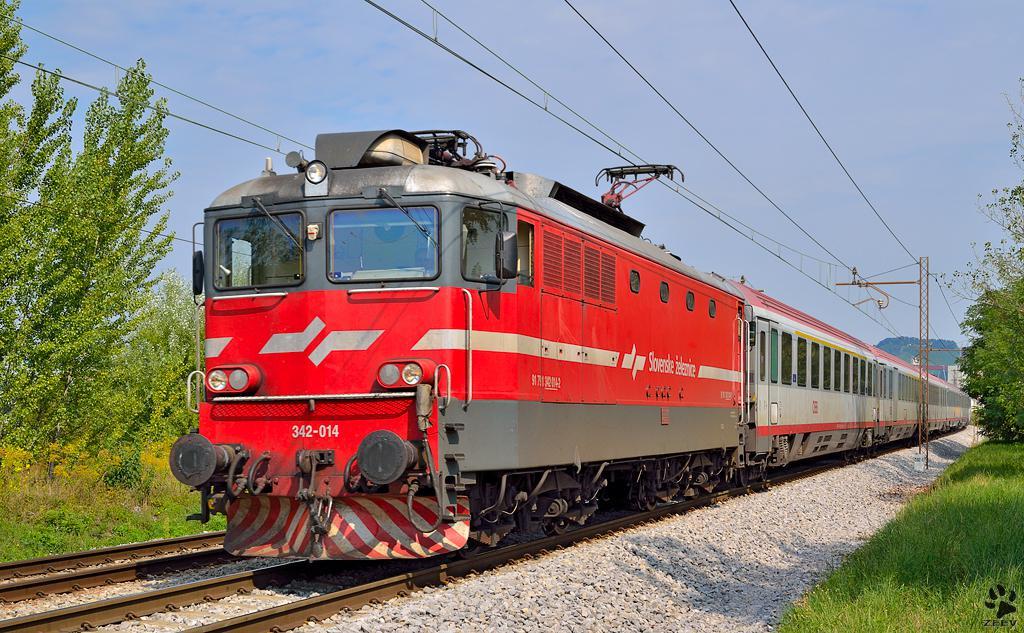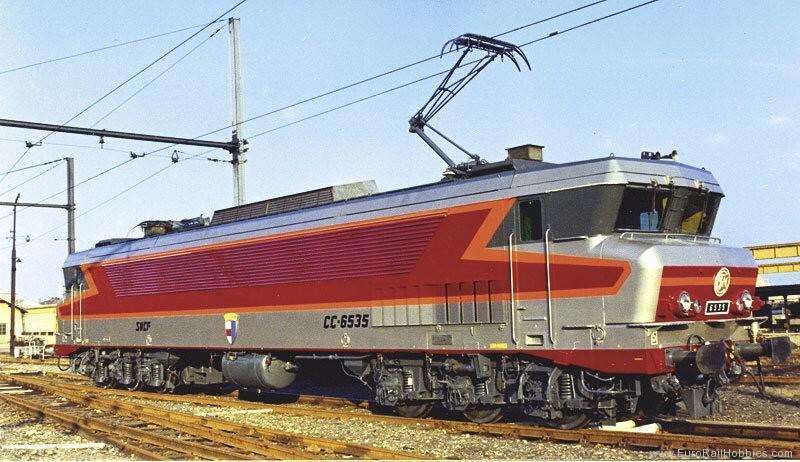The first image is the image on the left, the second image is the image on the right. Examine the images to the left and right. Is the description "The train engine in one of the images is bright red." accurate? Answer yes or no. Yes. 